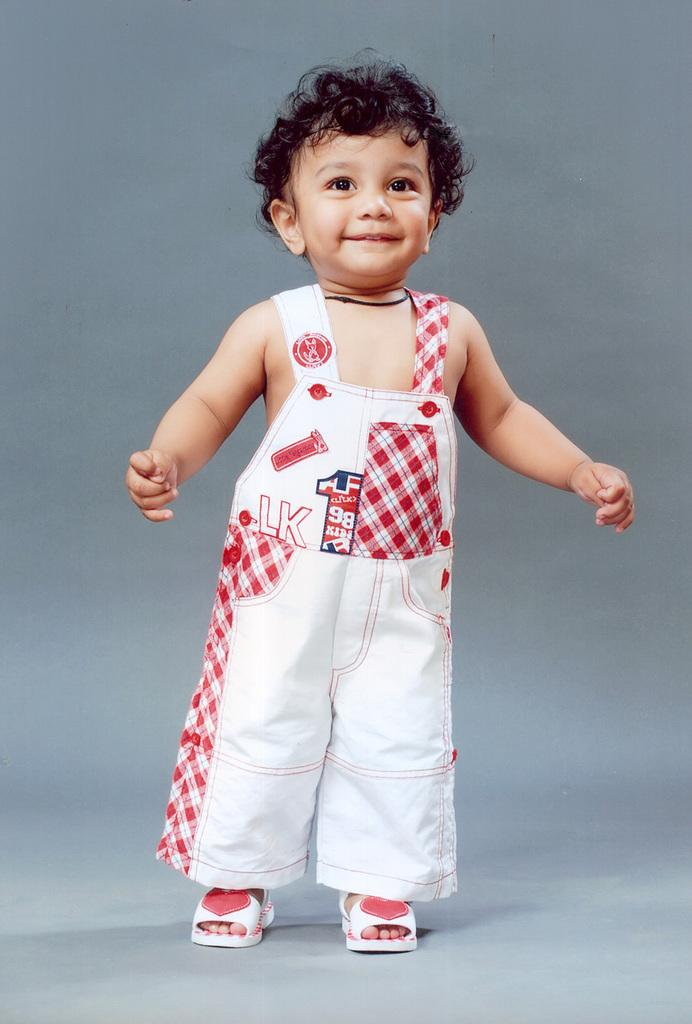What is the main subject of the image? The main subject of the image is a kid. What is the kid wearing in the image? The kid is wearing clothes and footwear. What is the color of the background in the image? The background of the image is gray. What type of cushion is the kid sitting on in the image? There is no cushion present in the image; the kid's footwear is visible, but there is no mention of a cushion. Can you see a chessboard in the image? There is no chessboard present in the image. 